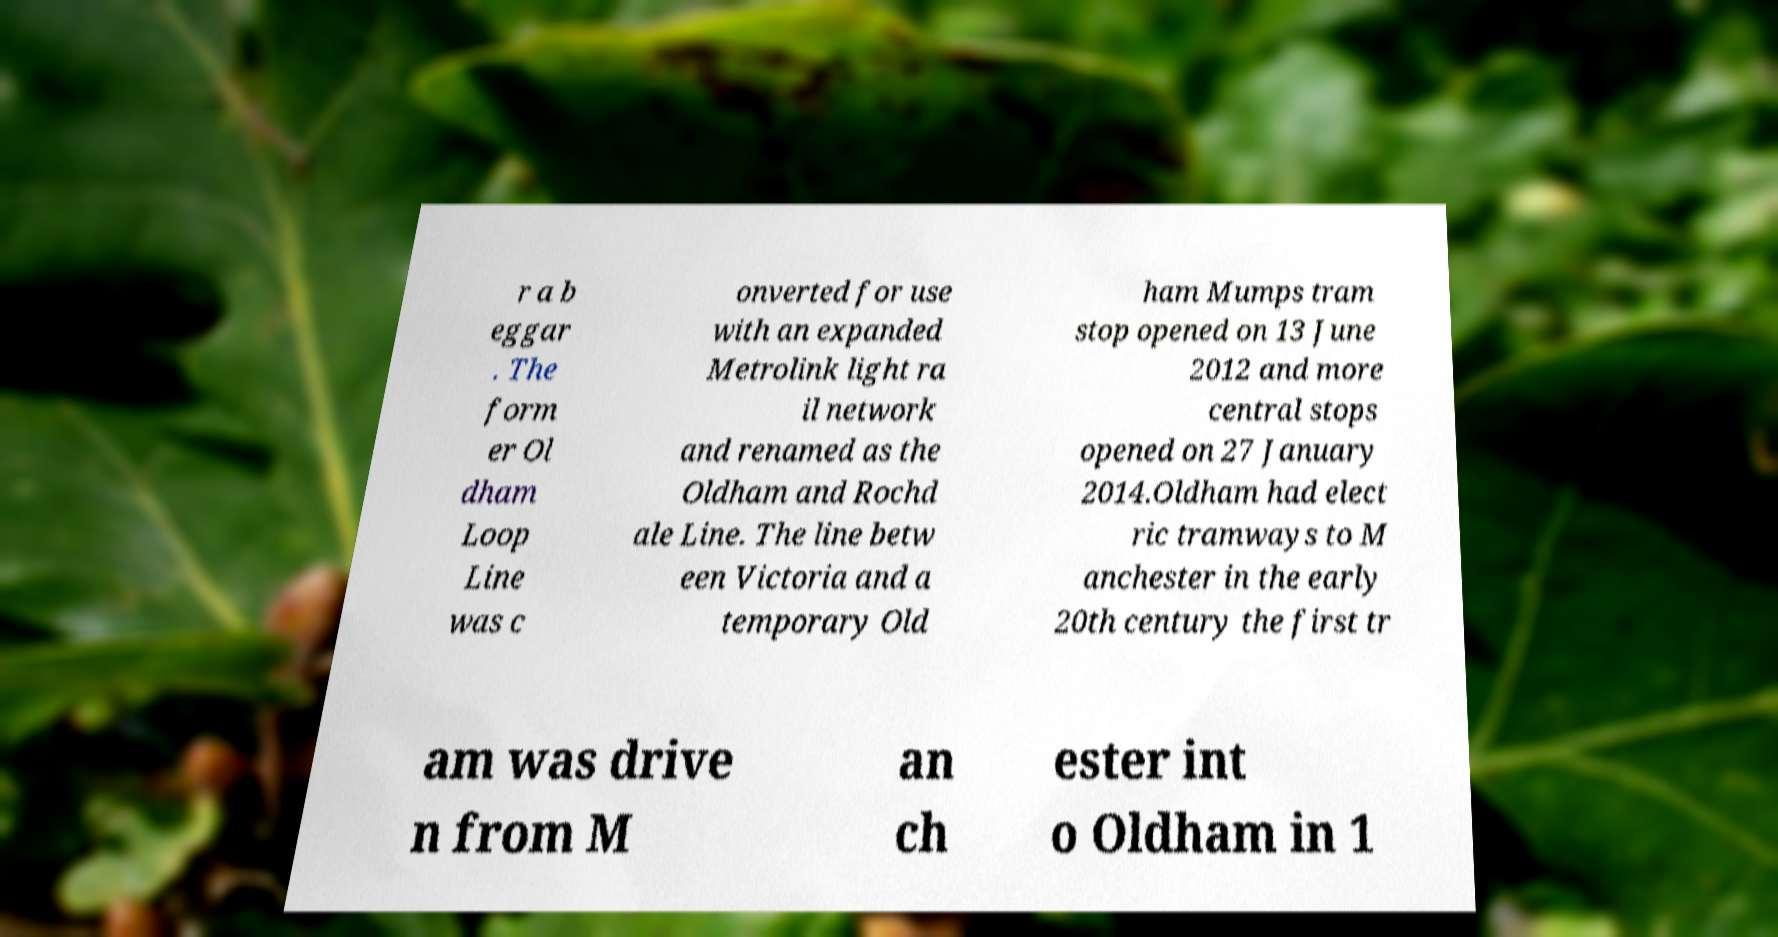Please identify and transcribe the text found in this image. r a b eggar . The form er Ol dham Loop Line was c onverted for use with an expanded Metrolink light ra il network and renamed as the Oldham and Rochd ale Line. The line betw een Victoria and a temporary Old ham Mumps tram stop opened on 13 June 2012 and more central stops opened on 27 January 2014.Oldham had elect ric tramways to M anchester in the early 20th century the first tr am was drive n from M an ch ester int o Oldham in 1 